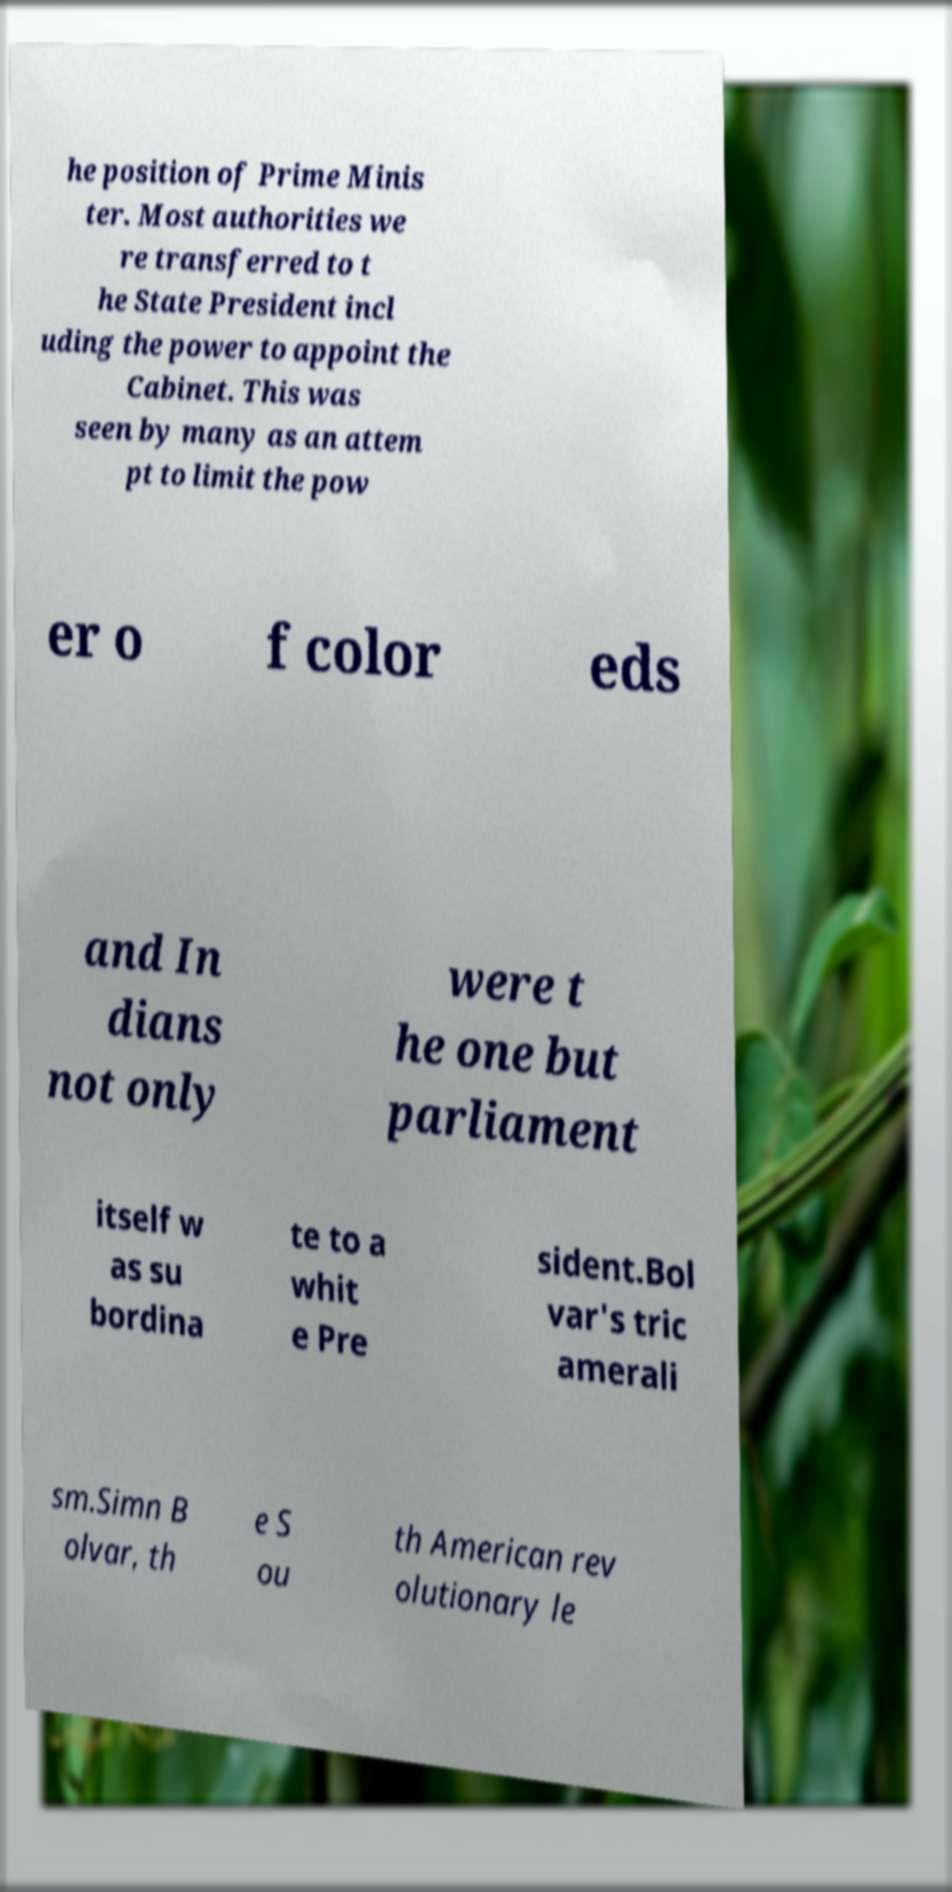For documentation purposes, I need the text within this image transcribed. Could you provide that? he position of Prime Minis ter. Most authorities we re transferred to t he State President incl uding the power to appoint the Cabinet. This was seen by many as an attem pt to limit the pow er o f color eds and In dians not only were t he one but parliament itself w as su bordina te to a whit e Pre sident.Bol var's tric amerali sm.Simn B olvar, th e S ou th American rev olutionary le 